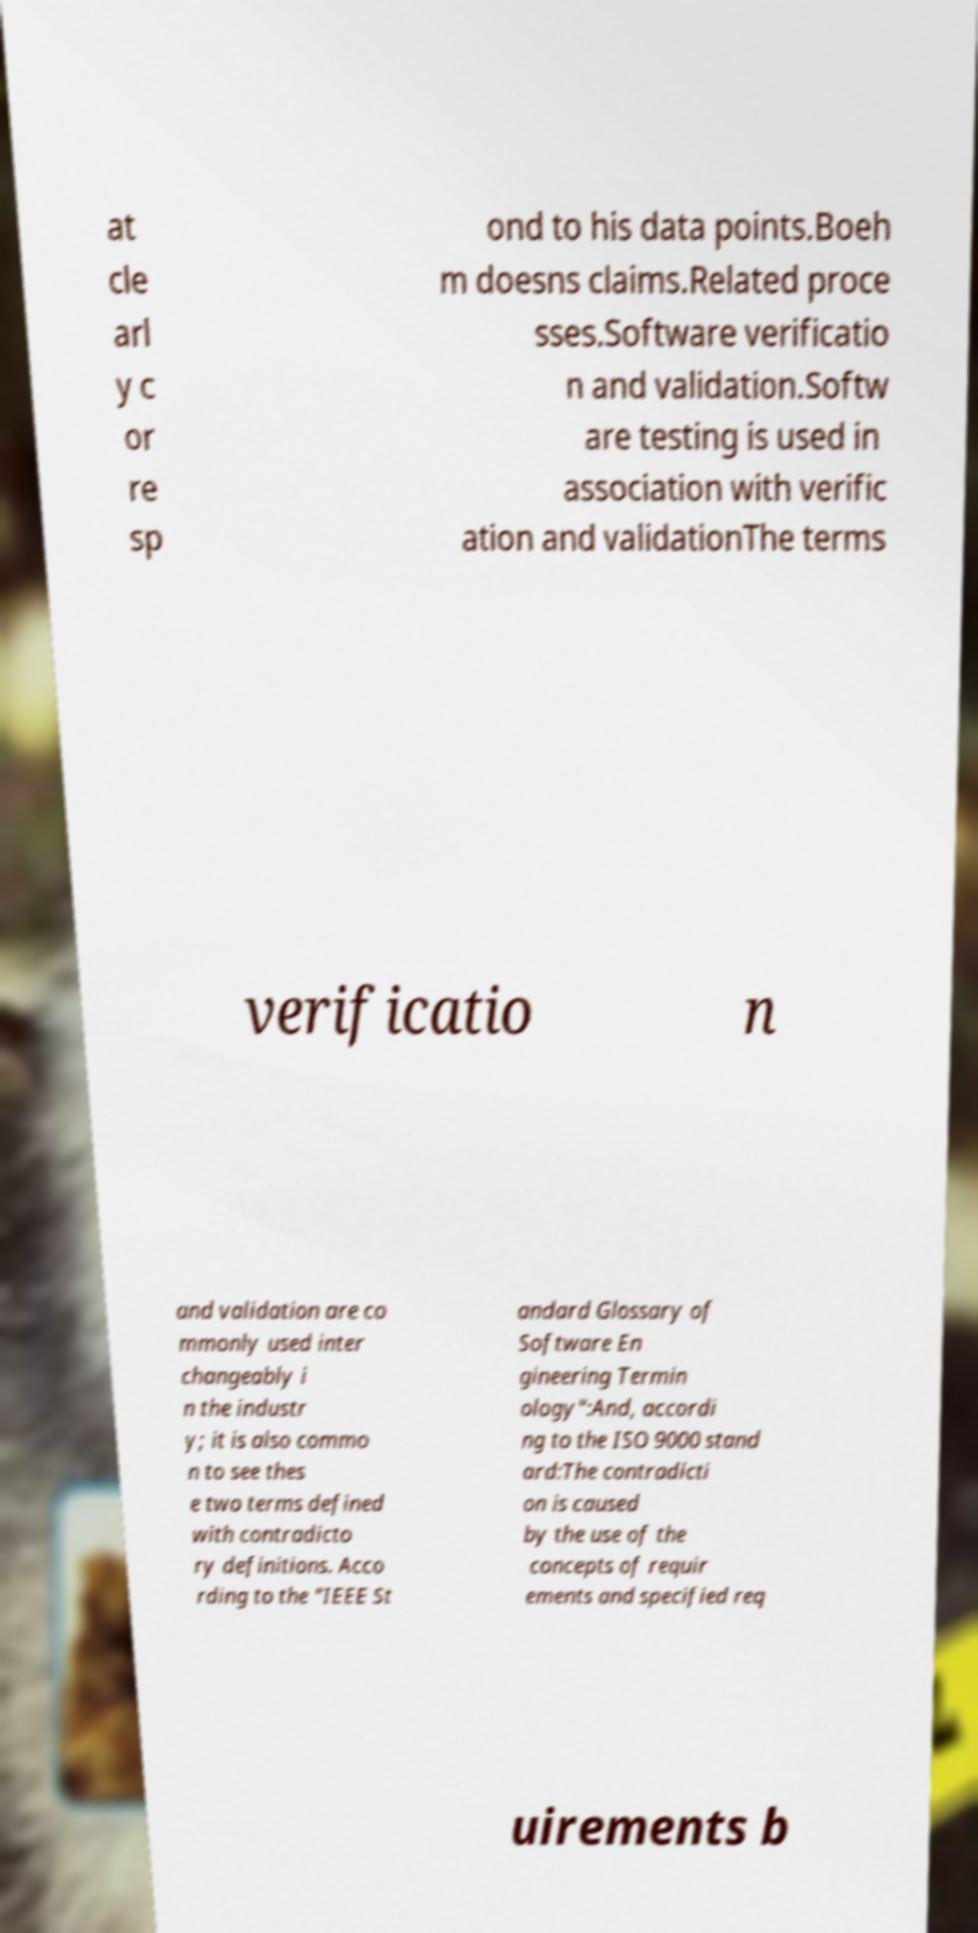Please identify and transcribe the text found in this image. at cle arl y c or re sp ond to his data points.Boeh m doesns claims.Related proce sses.Software verificatio n and validation.Softw are testing is used in association with verific ation and validationThe terms verificatio n and validation are co mmonly used inter changeably i n the industr y; it is also commo n to see thes e two terms defined with contradicto ry definitions. Acco rding to the "IEEE St andard Glossary of Software En gineering Termin ology":And, accordi ng to the ISO 9000 stand ard:The contradicti on is caused by the use of the concepts of requir ements and specified req uirements b 